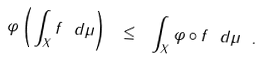<formula> <loc_0><loc_0><loc_500><loc_500>\varphi \left ( \int _ { X } f \ d \mu \right ) \ \leq \ \int _ { X } \varphi \circ f \ d \mu \ .</formula> 